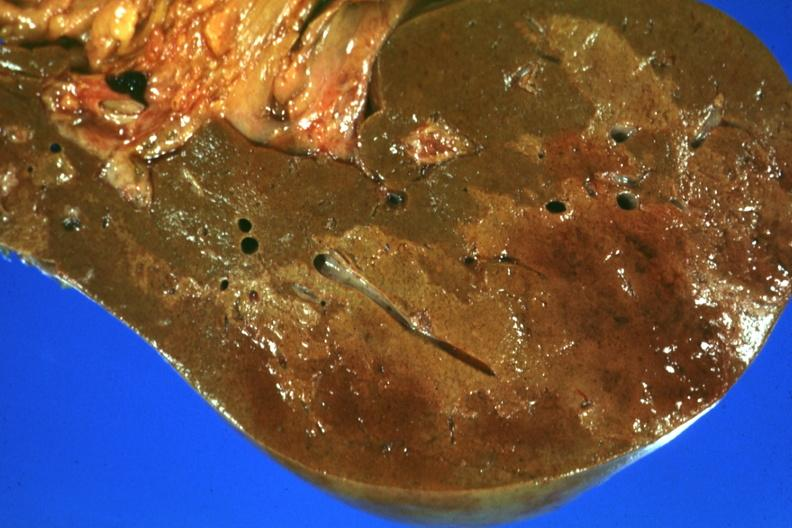does angiogram saphenous vein bypass graft show frontal section with large patch of central infarction well seen?
Answer the question using a single word or phrase. No 